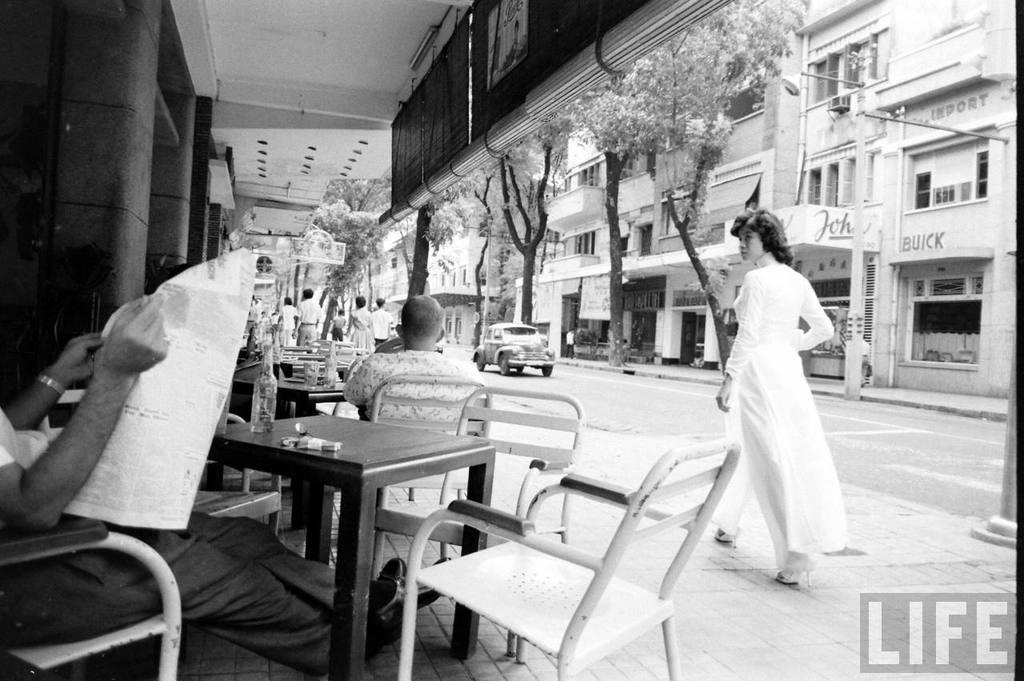Describe this image in one or two sentences. This image is taken in outdoors. There are few people in this image. In the left side of the image a man is sitting on a chair and reading news paper. In the right side of the image a girl is walking in a street. At the top of the image there is a roof. At the background there are few trees and buildings with windows and doors, on the road there is a vehicle. In the middle of the image there were few chairs and table. 